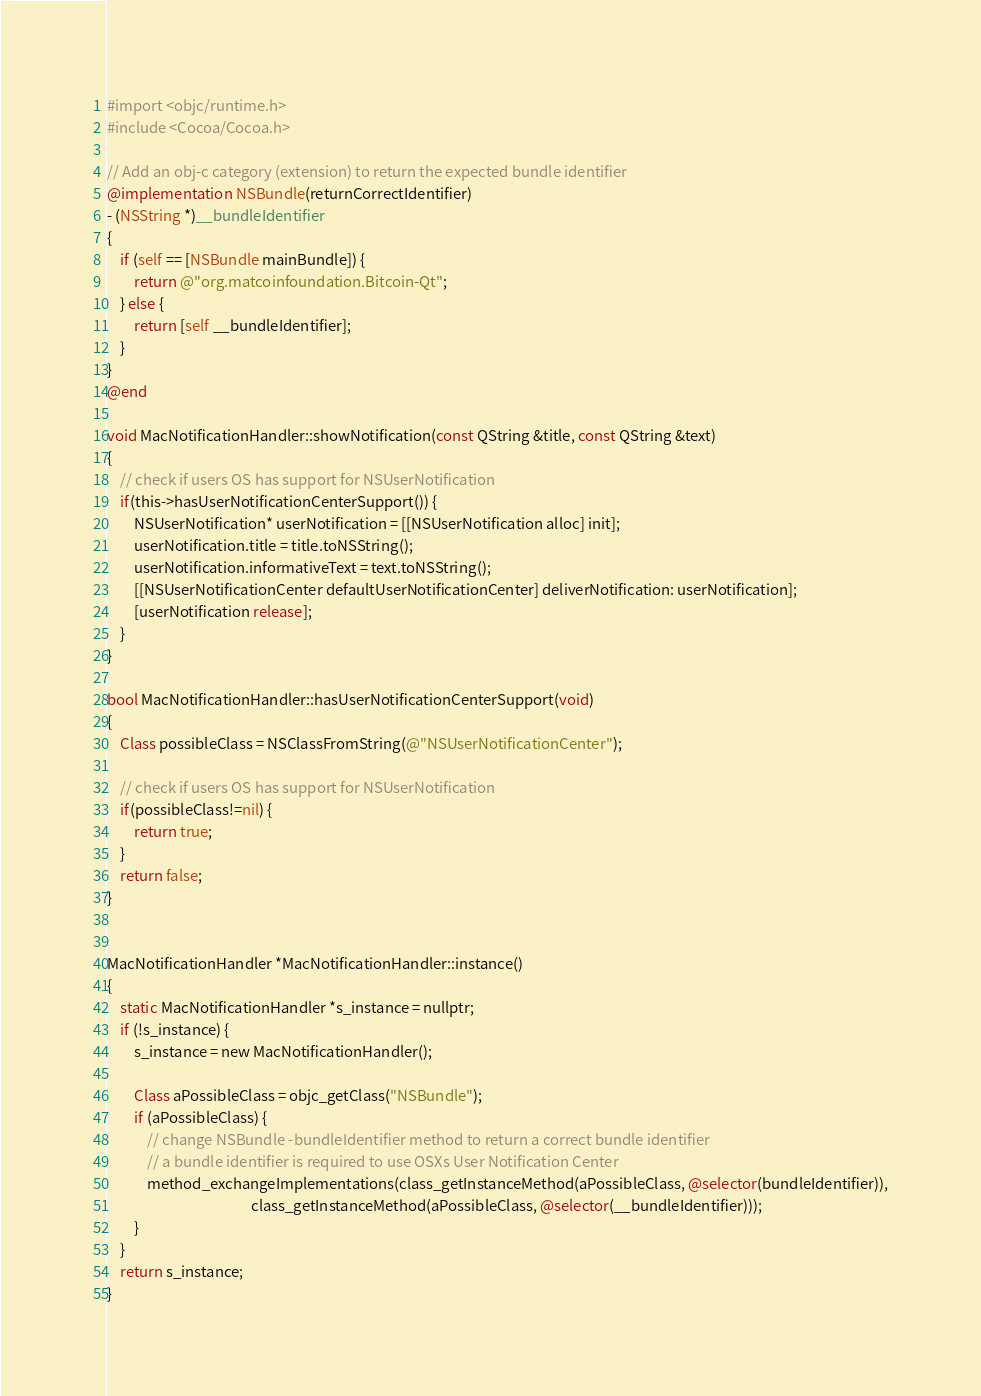Convert code to text. <code><loc_0><loc_0><loc_500><loc_500><_ObjectiveC_>#import <objc/runtime.h>
#include <Cocoa/Cocoa.h>

// Add an obj-c category (extension) to return the expected bundle identifier
@implementation NSBundle(returnCorrectIdentifier)
- (NSString *)__bundleIdentifier
{
    if (self == [NSBundle mainBundle]) {
        return @"org.matcoinfoundation.Bitcoin-Qt";
    } else {
        return [self __bundleIdentifier];
    }
}
@end

void MacNotificationHandler::showNotification(const QString &title, const QString &text)
{
    // check if users OS has support for NSUserNotification
    if(this->hasUserNotificationCenterSupport()) {
        NSUserNotification* userNotification = [[NSUserNotification alloc] init];
        userNotification.title = title.toNSString();
        userNotification.informativeText = text.toNSString();
        [[NSUserNotificationCenter defaultUserNotificationCenter] deliverNotification: userNotification];
        [userNotification release];
    }
}

bool MacNotificationHandler::hasUserNotificationCenterSupport(void)
{
    Class possibleClass = NSClassFromString(@"NSUserNotificationCenter");

    // check if users OS has support for NSUserNotification
    if(possibleClass!=nil) {
        return true;
    }
    return false;
}


MacNotificationHandler *MacNotificationHandler::instance()
{
    static MacNotificationHandler *s_instance = nullptr;
    if (!s_instance) {
        s_instance = new MacNotificationHandler();

        Class aPossibleClass = objc_getClass("NSBundle");
        if (aPossibleClass) {
            // change NSBundle -bundleIdentifier method to return a correct bundle identifier
            // a bundle identifier is required to use OSXs User Notification Center
            method_exchangeImplementations(class_getInstanceMethod(aPossibleClass, @selector(bundleIdentifier)),
                                           class_getInstanceMethod(aPossibleClass, @selector(__bundleIdentifier)));
        }
    }
    return s_instance;
}
</code> 